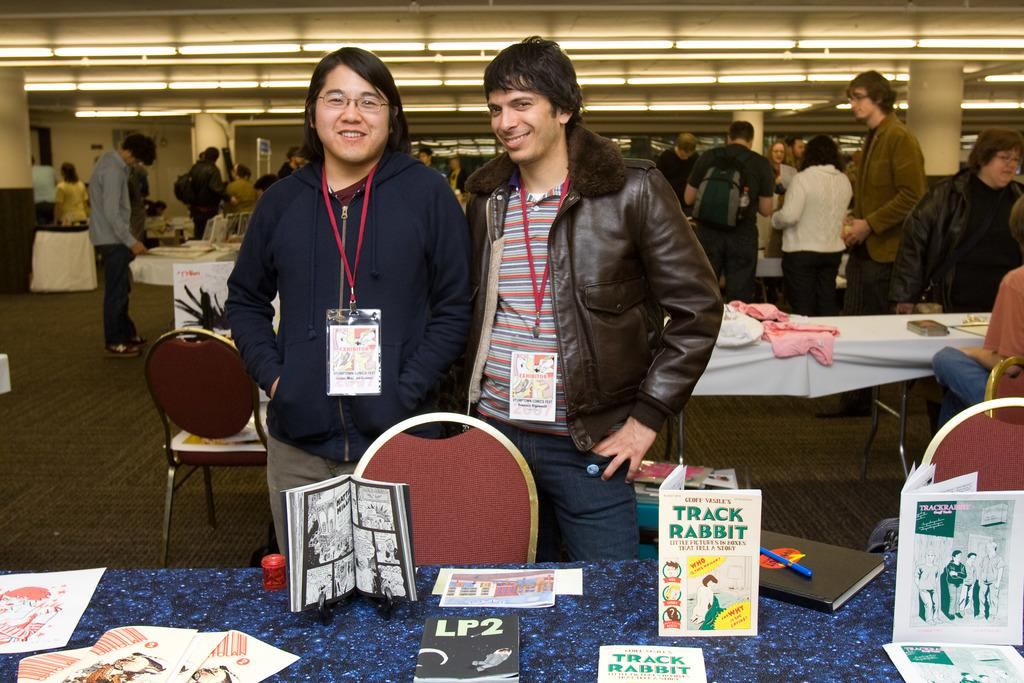<image>
Provide a brief description of the given image. A paperback book called Track Rabbit sits on a display table. 